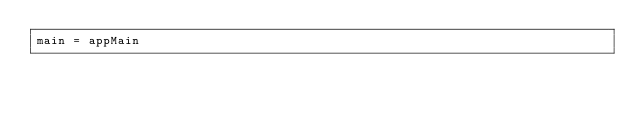Convert code to text. <code><loc_0><loc_0><loc_500><loc_500><_Haskell_>main = appMain
</code> 